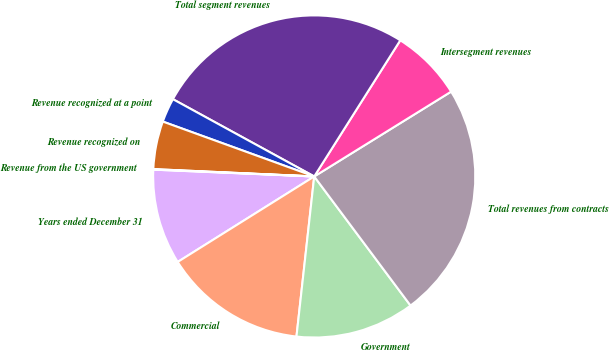Convert chart. <chart><loc_0><loc_0><loc_500><loc_500><pie_chart><fcel>Years ended December 31<fcel>Commercial<fcel>Government<fcel>Total revenues from contracts<fcel>Intersegment revenues<fcel>Total segment revenues<fcel>Revenue recognized at a point<fcel>Revenue recognized on<fcel>Revenue from the US government<nl><fcel>9.58%<fcel>14.34%<fcel>11.96%<fcel>23.63%<fcel>7.2%<fcel>26.01%<fcel>2.43%<fcel>4.81%<fcel>0.05%<nl></chart> 